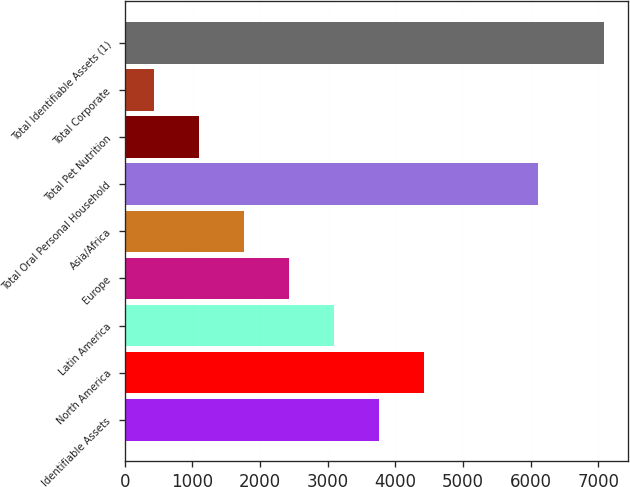Convert chart to OTSL. <chart><loc_0><loc_0><loc_500><loc_500><bar_chart><fcel>Identifiable Assets<fcel>North America<fcel>Latin America<fcel>Europe<fcel>Asia/Africa<fcel>Total Oral Personal Household<fcel>Total Pet Nutrition<fcel>Total Corporate<fcel>Total Identifiable Assets (1)<nl><fcel>3759.5<fcel>4425.04<fcel>3093.96<fcel>2428.42<fcel>1762.88<fcel>6102.9<fcel>1097.34<fcel>431.8<fcel>7087.2<nl></chart> 